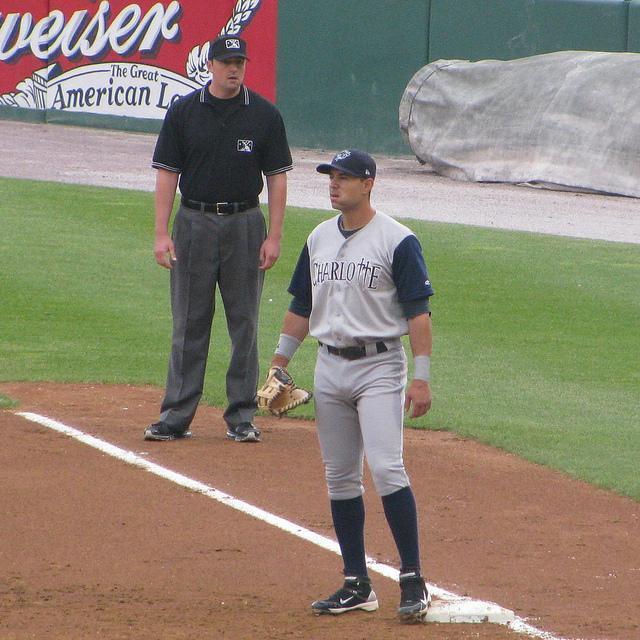How many people can you see?
Give a very brief answer. 2. 